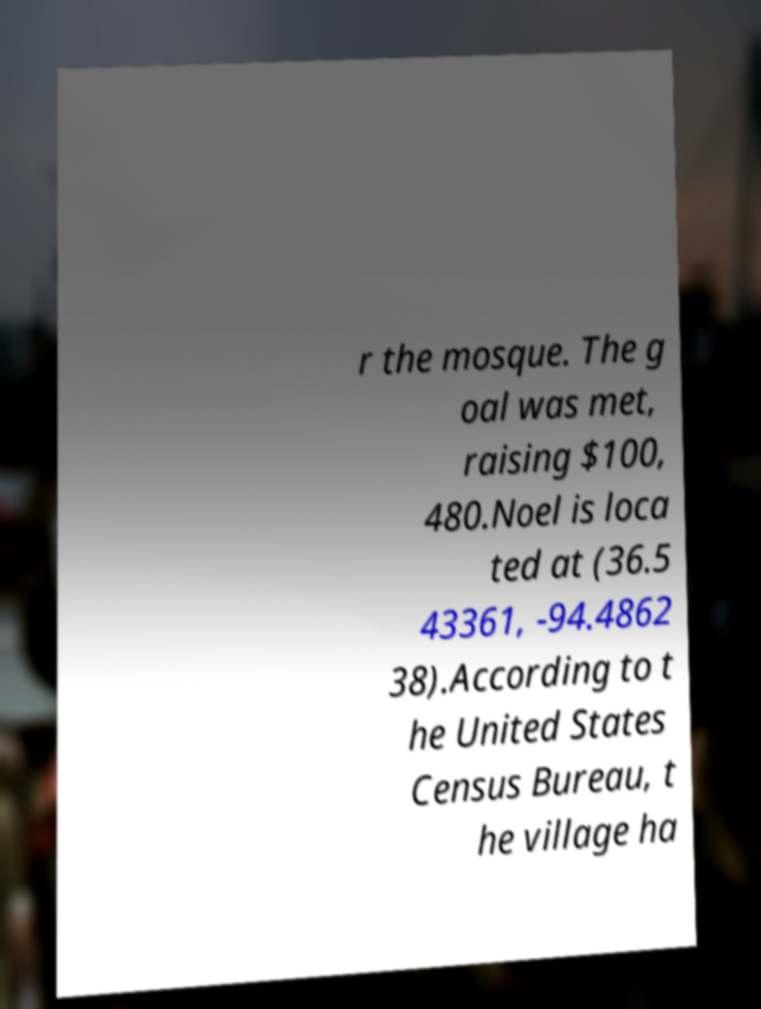Please read and relay the text visible in this image. What does it say? r the mosque. The g oal was met, raising $100, 480.Noel is loca ted at (36.5 43361, -94.4862 38).According to t he United States Census Bureau, t he village ha 